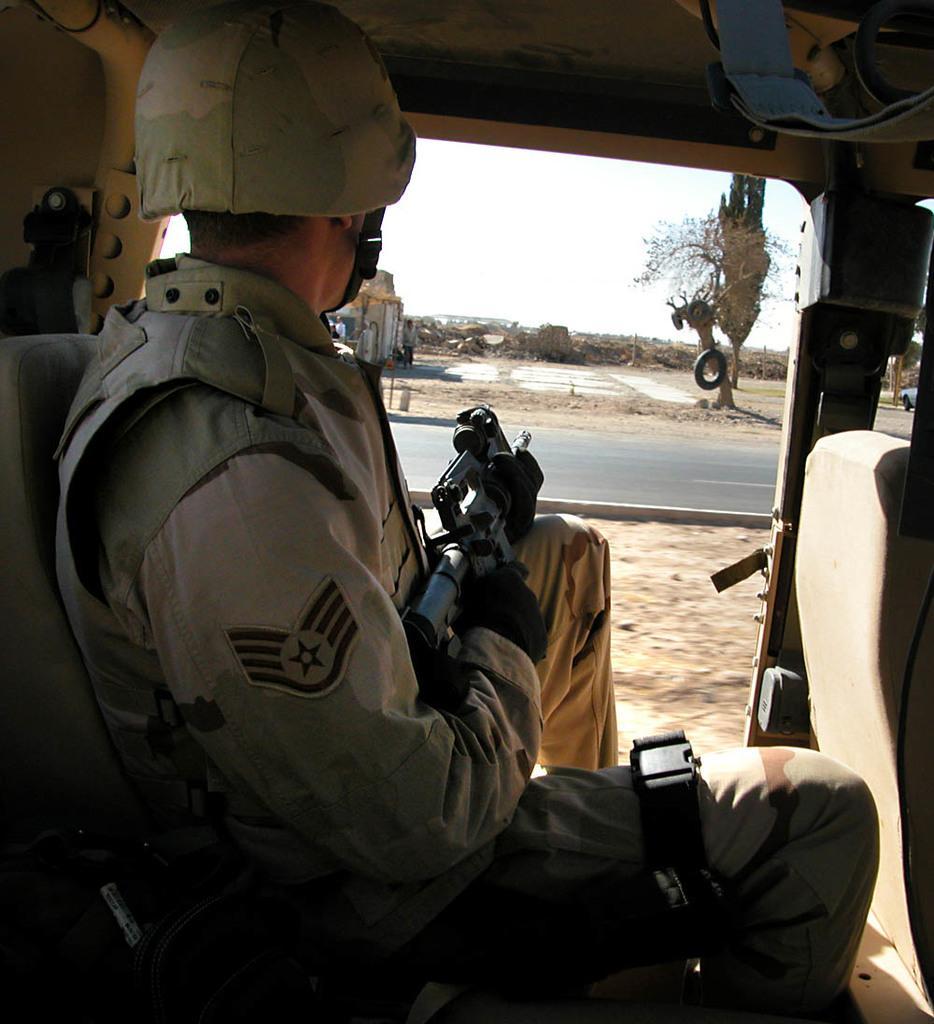How would you summarize this image in a sentence or two? In this image we can see one person sitting in the vehicle and holding a gun. There is one tire on the tree, some objects on the ground, one man standing near the wall, one road, one car, some plants, some grass on the ground and at the top there is the sky. 